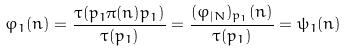<formula> <loc_0><loc_0><loc_500><loc_500>\varphi _ { 1 } ( n ) = \frac { \tau ( p _ { 1 } \pi ( n ) p _ { 1 } ) } { \tau ( p _ { 1 } ) } = \frac { ( \varphi _ { | N } ) _ { p _ { 1 } } ( n ) } { \tau ( p _ { 1 } ) } = \psi _ { 1 } ( n )</formula> 